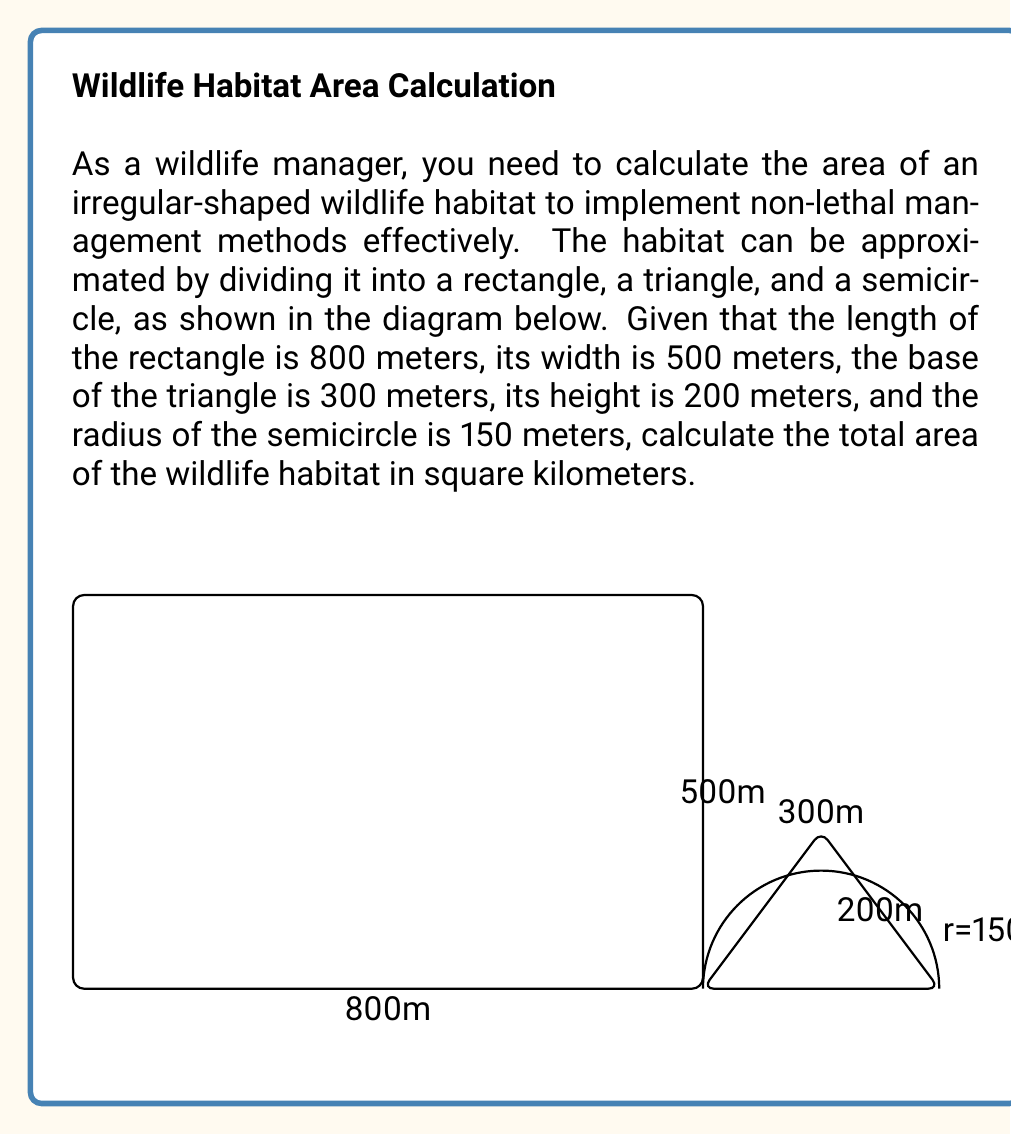Show me your answer to this math problem. To solve this problem, we need to calculate the areas of each geometric shape separately and then sum them up. Let's break it down step by step:

1. Rectangle area:
   $A_r = l \times w$
   $A_r = 800 \text{ m} \times 500 \text{ m} = 400,000 \text{ m}^2$

2. Triangle area:
   $A_t = \frac{1}{2} \times b \times h$
   $A_t = \frac{1}{2} \times 300 \text{ m} \times 200 \text{ m} = 30,000 \text{ m}^2$

3. Semicircle area:
   $A_s = \frac{1}{2} \times \pi r^2$
   $A_s = \frac{1}{2} \times \pi \times (150 \text{ m})^2 = 35,343.75 \text{ m}^2$

Now, let's sum up all the areas:

$A_{total} = A_r + A_t + A_s$
$A_{total} = 400,000 \text{ m}^2 + 30,000 \text{ m}^2 + 35,343.75 \text{ m}^2$
$A_{total} = 465,343.75 \text{ m}^2$

To convert the area from square meters to square kilometers, we divide by 1,000,000:

$A_{total} = \frac{465,343.75 \text{ m}^2}{1,000,000 \text{ m}^2/\text{km}^2} = 0.46534375 \text{ km}^2$

Rounding to four decimal places:

$A_{total} \approx 0.4653 \text{ km}^2$
Answer: The total area of the irregular-shaped wildlife habitat is approximately 0.4653 km². 